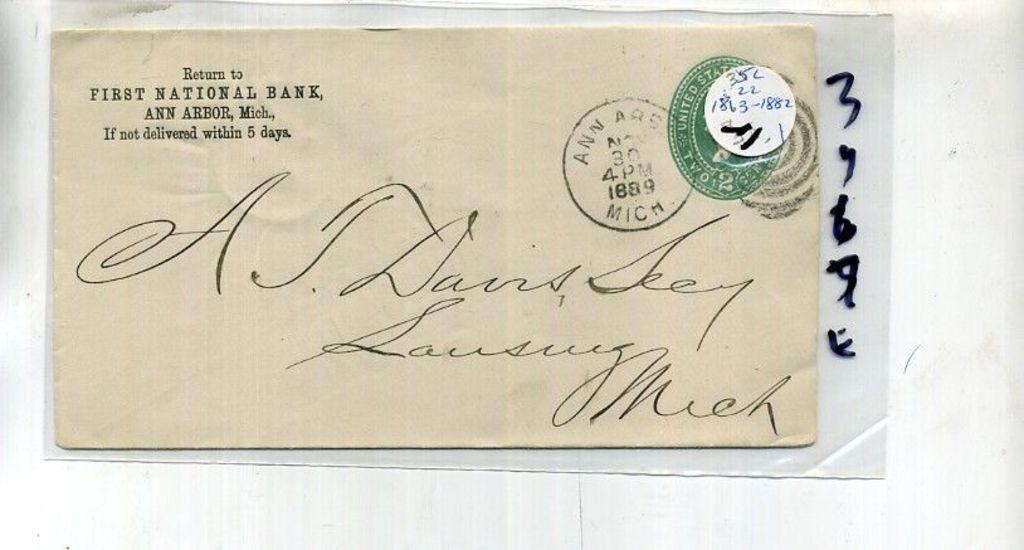Where is the return address?
Your answer should be very brief. Ann arbor, michigan. What year was this sent?
Your answer should be very brief. 1889. 